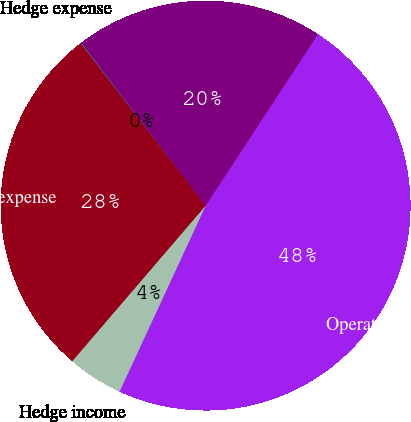Convert chart. <chart><loc_0><loc_0><loc_500><loc_500><pie_chart><fcel>Operating interest income<fcel>Hedge income<fcel>Operating interest expense<fcel>Hedge expense<fcel>Net operating interest income<nl><fcel>47.67%<fcel>4.38%<fcel>28.3%<fcel>0.04%<fcel>19.61%<nl></chart> 